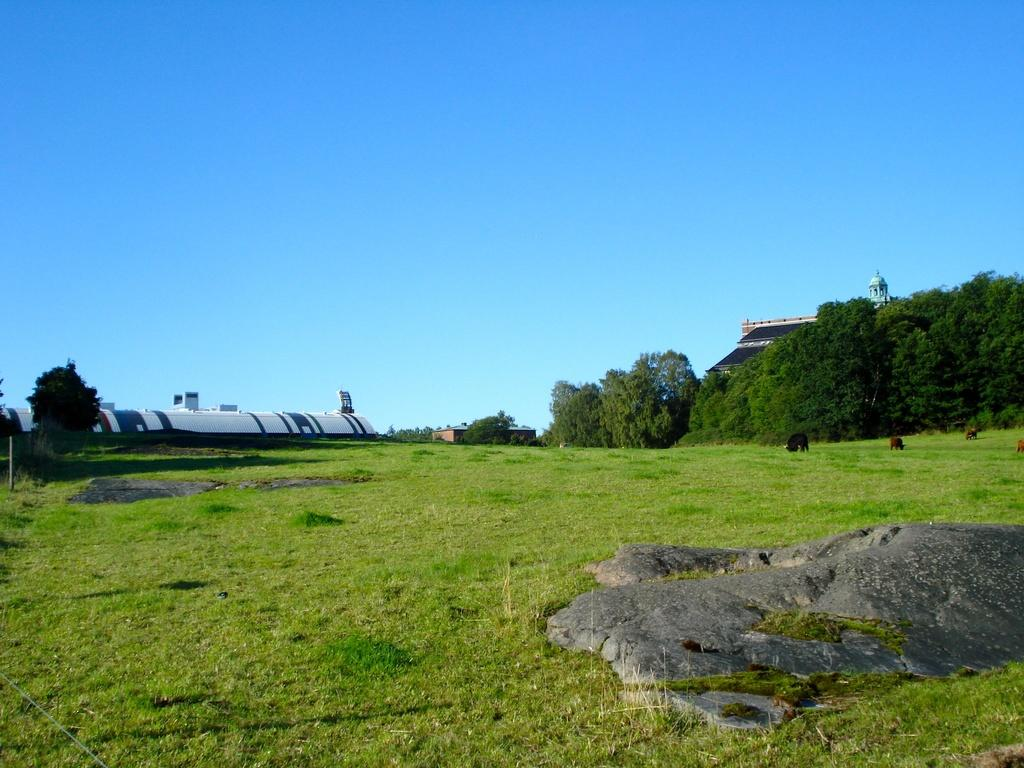What type of vegetation can be seen in the image? There are trees and grass in the image. What other objects or features can be seen in the image? There is a rock and a house in the image. What is visible in the background of the image? The sky is visible in the image. Can you describe the girl's journey in the image? There is no girl present in the image, so it is not possible to describe her journey. 